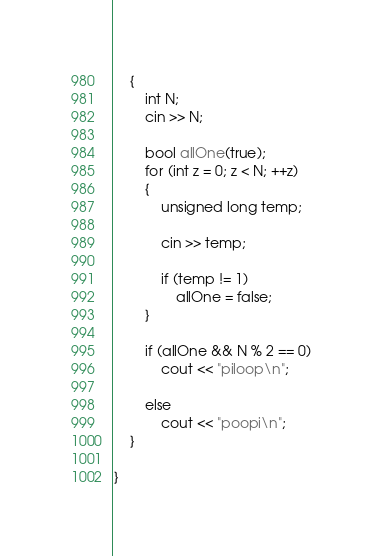Convert code to text. <code><loc_0><loc_0><loc_500><loc_500><_C++_>	{
		int N;
		cin >> N;
		
		bool allOne(true);
		for (int z = 0; z < N; ++z)
		{
			unsigned long temp;
			
			cin >> temp;
			
			if (temp != 1)
				allOne = false;
		}
		
		if (allOne && N % 2 == 0)
			cout << "piloop\n";
		
		else
			cout << "poopi\n";
	}

}</code> 